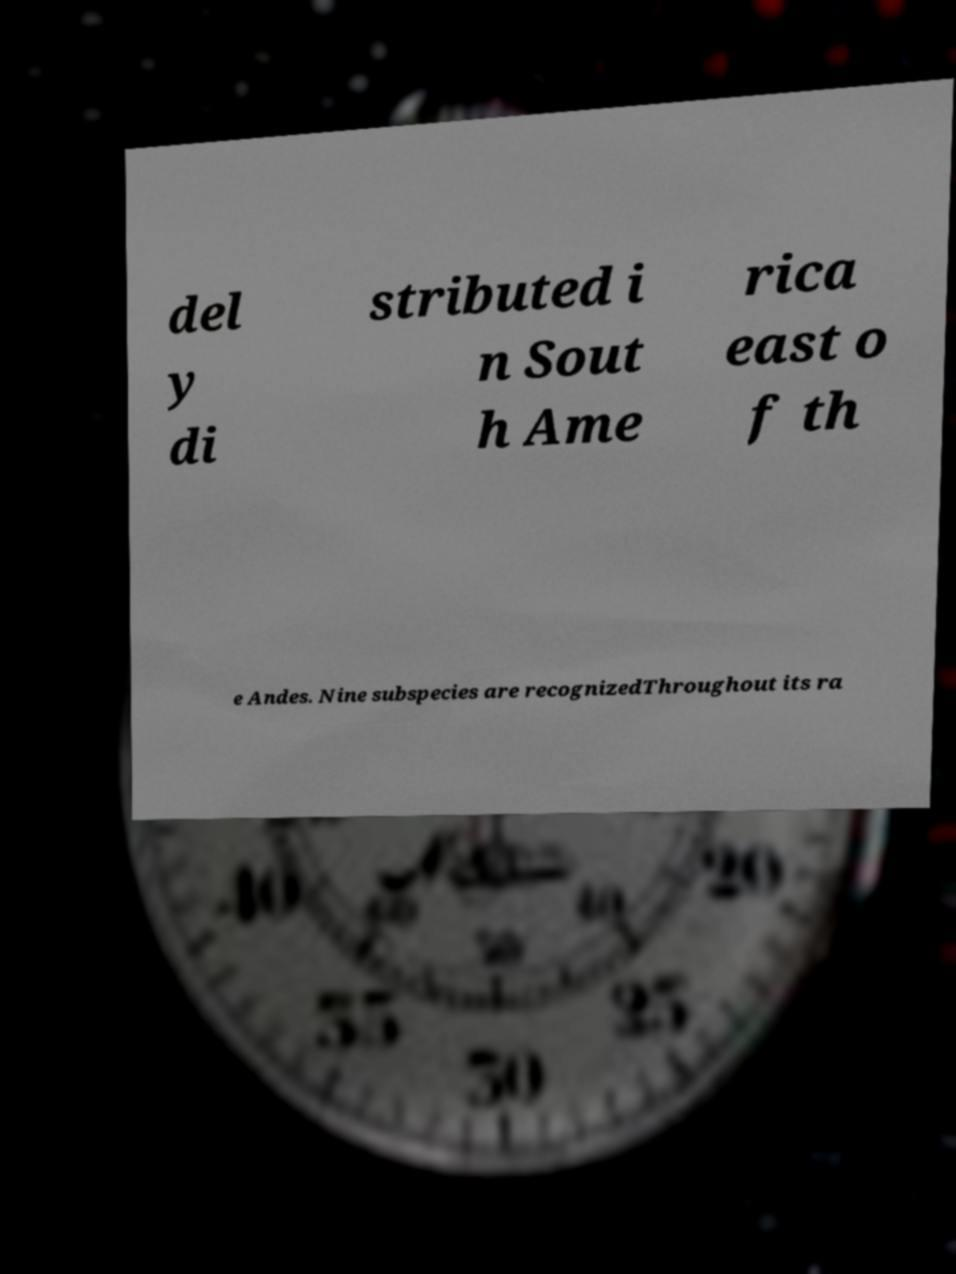Can you accurately transcribe the text from the provided image for me? del y di stributed i n Sout h Ame rica east o f th e Andes. Nine subspecies are recognizedThroughout its ra 